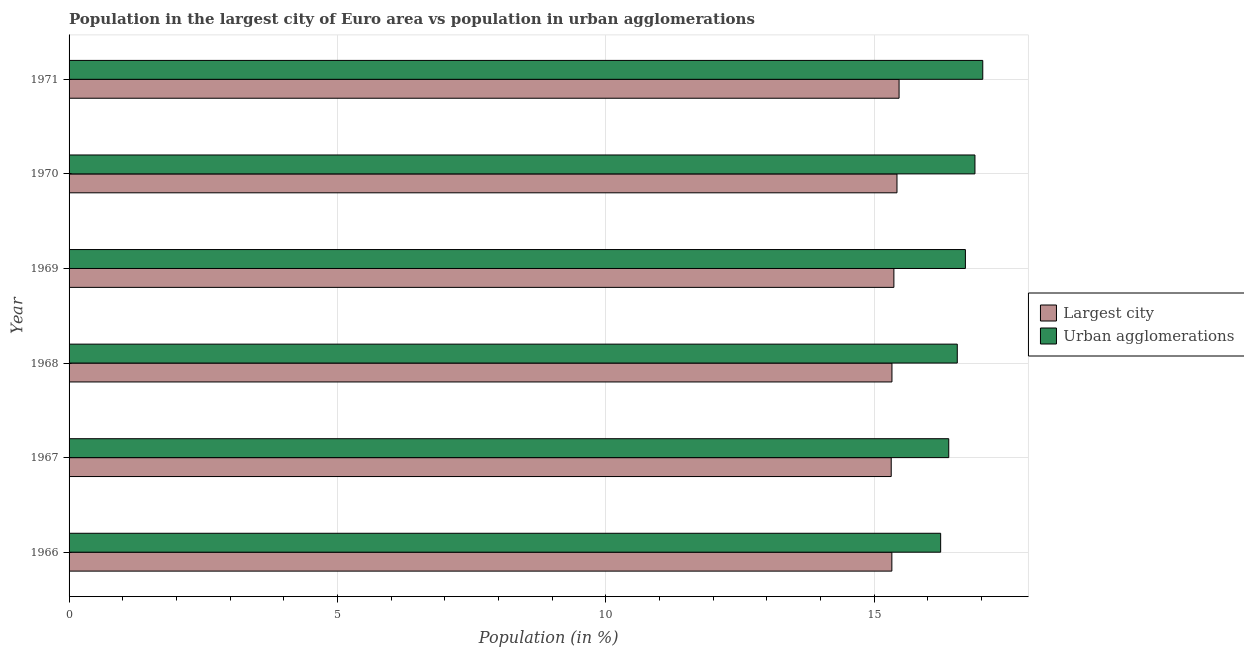How many different coloured bars are there?
Keep it short and to the point. 2. How many groups of bars are there?
Provide a short and direct response. 6. Are the number of bars per tick equal to the number of legend labels?
Ensure brevity in your answer.  Yes. How many bars are there on the 6th tick from the top?
Provide a succinct answer. 2. What is the label of the 5th group of bars from the top?
Provide a short and direct response. 1967. In how many cases, is the number of bars for a given year not equal to the number of legend labels?
Your answer should be very brief. 0. What is the population in the largest city in 1969?
Provide a short and direct response. 15.37. Across all years, what is the maximum population in the largest city?
Provide a short and direct response. 15.47. Across all years, what is the minimum population in the largest city?
Provide a succinct answer. 15.32. In which year was the population in urban agglomerations minimum?
Your response must be concise. 1966. What is the total population in the largest city in the graph?
Provide a short and direct response. 92.24. What is the difference between the population in the largest city in 1967 and that in 1971?
Your response must be concise. -0.15. What is the difference between the population in urban agglomerations in 1971 and the population in the largest city in 1967?
Offer a very short reply. 1.71. What is the average population in the largest city per year?
Offer a terse response. 15.37. In the year 1966, what is the difference between the population in the largest city and population in urban agglomerations?
Offer a very short reply. -0.91. In how many years, is the population in urban agglomerations greater than 9 %?
Your answer should be very brief. 6. What is the ratio of the population in the largest city in 1969 to that in 1970?
Give a very brief answer. 1. Is the difference between the population in the largest city in 1967 and 1970 greater than the difference between the population in urban agglomerations in 1967 and 1970?
Offer a very short reply. Yes. What is the difference between the highest and the second highest population in urban agglomerations?
Your answer should be compact. 0.14. Is the sum of the population in urban agglomerations in 1967 and 1971 greater than the maximum population in the largest city across all years?
Offer a very short reply. Yes. What does the 2nd bar from the top in 1966 represents?
Keep it short and to the point. Largest city. What does the 2nd bar from the bottom in 1970 represents?
Offer a terse response. Urban agglomerations. Does the graph contain grids?
Your answer should be very brief. Yes. What is the title of the graph?
Offer a terse response. Population in the largest city of Euro area vs population in urban agglomerations. Does "IMF concessional" appear as one of the legend labels in the graph?
Give a very brief answer. No. What is the label or title of the X-axis?
Your answer should be very brief. Population (in %). What is the Population (in %) in Largest city in 1966?
Make the answer very short. 15.33. What is the Population (in %) of Urban agglomerations in 1966?
Offer a terse response. 16.24. What is the Population (in %) in Largest city in 1967?
Ensure brevity in your answer.  15.32. What is the Population (in %) in Urban agglomerations in 1967?
Your answer should be compact. 16.39. What is the Population (in %) of Largest city in 1968?
Provide a succinct answer. 15.33. What is the Population (in %) in Urban agglomerations in 1968?
Your answer should be compact. 16.55. What is the Population (in %) of Largest city in 1969?
Make the answer very short. 15.37. What is the Population (in %) of Urban agglomerations in 1969?
Give a very brief answer. 16.7. What is the Population (in %) in Largest city in 1970?
Ensure brevity in your answer.  15.43. What is the Population (in %) of Urban agglomerations in 1970?
Provide a short and direct response. 16.88. What is the Population (in %) of Largest city in 1971?
Provide a short and direct response. 15.47. What is the Population (in %) of Urban agglomerations in 1971?
Offer a terse response. 17.02. Across all years, what is the maximum Population (in %) in Largest city?
Provide a short and direct response. 15.47. Across all years, what is the maximum Population (in %) in Urban agglomerations?
Give a very brief answer. 17.02. Across all years, what is the minimum Population (in %) of Largest city?
Offer a very short reply. 15.32. Across all years, what is the minimum Population (in %) of Urban agglomerations?
Provide a succinct answer. 16.24. What is the total Population (in %) of Largest city in the graph?
Ensure brevity in your answer.  92.24. What is the total Population (in %) of Urban agglomerations in the graph?
Ensure brevity in your answer.  99.79. What is the difference between the Population (in %) in Largest city in 1966 and that in 1967?
Give a very brief answer. 0.01. What is the difference between the Population (in %) in Urban agglomerations in 1966 and that in 1967?
Ensure brevity in your answer.  -0.15. What is the difference between the Population (in %) of Largest city in 1966 and that in 1968?
Your response must be concise. -0. What is the difference between the Population (in %) in Urban agglomerations in 1966 and that in 1968?
Make the answer very short. -0.31. What is the difference between the Population (in %) of Largest city in 1966 and that in 1969?
Your answer should be compact. -0.04. What is the difference between the Population (in %) of Urban agglomerations in 1966 and that in 1969?
Your response must be concise. -0.46. What is the difference between the Population (in %) in Largest city in 1966 and that in 1970?
Keep it short and to the point. -0.1. What is the difference between the Population (in %) of Urban agglomerations in 1966 and that in 1970?
Your answer should be very brief. -0.64. What is the difference between the Population (in %) of Largest city in 1966 and that in 1971?
Make the answer very short. -0.13. What is the difference between the Population (in %) of Urban agglomerations in 1966 and that in 1971?
Give a very brief answer. -0.78. What is the difference between the Population (in %) of Largest city in 1967 and that in 1968?
Offer a very short reply. -0.01. What is the difference between the Population (in %) in Urban agglomerations in 1967 and that in 1968?
Your answer should be compact. -0.16. What is the difference between the Population (in %) of Urban agglomerations in 1967 and that in 1969?
Give a very brief answer. -0.31. What is the difference between the Population (in %) in Largest city in 1967 and that in 1970?
Your answer should be compact. -0.11. What is the difference between the Population (in %) of Urban agglomerations in 1967 and that in 1970?
Keep it short and to the point. -0.49. What is the difference between the Population (in %) in Largest city in 1967 and that in 1971?
Provide a short and direct response. -0.15. What is the difference between the Population (in %) in Urban agglomerations in 1967 and that in 1971?
Give a very brief answer. -0.63. What is the difference between the Population (in %) of Largest city in 1968 and that in 1969?
Provide a succinct answer. -0.04. What is the difference between the Population (in %) of Urban agglomerations in 1968 and that in 1969?
Give a very brief answer. -0.15. What is the difference between the Population (in %) in Largest city in 1968 and that in 1970?
Keep it short and to the point. -0.09. What is the difference between the Population (in %) in Urban agglomerations in 1968 and that in 1970?
Ensure brevity in your answer.  -0.33. What is the difference between the Population (in %) in Largest city in 1968 and that in 1971?
Offer a very short reply. -0.13. What is the difference between the Population (in %) in Urban agglomerations in 1968 and that in 1971?
Your answer should be very brief. -0.47. What is the difference between the Population (in %) in Largest city in 1969 and that in 1970?
Make the answer very short. -0.06. What is the difference between the Population (in %) in Urban agglomerations in 1969 and that in 1970?
Your response must be concise. -0.18. What is the difference between the Population (in %) of Largest city in 1969 and that in 1971?
Provide a succinct answer. -0.1. What is the difference between the Population (in %) of Urban agglomerations in 1969 and that in 1971?
Offer a very short reply. -0.32. What is the difference between the Population (in %) in Largest city in 1970 and that in 1971?
Provide a short and direct response. -0.04. What is the difference between the Population (in %) in Urban agglomerations in 1970 and that in 1971?
Provide a short and direct response. -0.15. What is the difference between the Population (in %) in Largest city in 1966 and the Population (in %) in Urban agglomerations in 1967?
Give a very brief answer. -1.06. What is the difference between the Population (in %) in Largest city in 1966 and the Population (in %) in Urban agglomerations in 1968?
Make the answer very short. -1.22. What is the difference between the Population (in %) in Largest city in 1966 and the Population (in %) in Urban agglomerations in 1969?
Provide a short and direct response. -1.37. What is the difference between the Population (in %) in Largest city in 1966 and the Population (in %) in Urban agglomerations in 1970?
Make the answer very short. -1.55. What is the difference between the Population (in %) in Largest city in 1966 and the Population (in %) in Urban agglomerations in 1971?
Offer a terse response. -1.69. What is the difference between the Population (in %) in Largest city in 1967 and the Population (in %) in Urban agglomerations in 1968?
Keep it short and to the point. -1.23. What is the difference between the Population (in %) in Largest city in 1967 and the Population (in %) in Urban agglomerations in 1969?
Your answer should be compact. -1.38. What is the difference between the Population (in %) in Largest city in 1967 and the Population (in %) in Urban agglomerations in 1970?
Offer a terse response. -1.56. What is the difference between the Population (in %) in Largest city in 1967 and the Population (in %) in Urban agglomerations in 1971?
Provide a short and direct response. -1.71. What is the difference between the Population (in %) of Largest city in 1968 and the Population (in %) of Urban agglomerations in 1969?
Ensure brevity in your answer.  -1.37. What is the difference between the Population (in %) of Largest city in 1968 and the Population (in %) of Urban agglomerations in 1970?
Offer a terse response. -1.55. What is the difference between the Population (in %) in Largest city in 1968 and the Population (in %) in Urban agglomerations in 1971?
Provide a short and direct response. -1.69. What is the difference between the Population (in %) of Largest city in 1969 and the Population (in %) of Urban agglomerations in 1970?
Offer a very short reply. -1.51. What is the difference between the Population (in %) in Largest city in 1969 and the Population (in %) in Urban agglomerations in 1971?
Ensure brevity in your answer.  -1.66. What is the difference between the Population (in %) of Largest city in 1970 and the Population (in %) of Urban agglomerations in 1971?
Keep it short and to the point. -1.6. What is the average Population (in %) in Largest city per year?
Give a very brief answer. 15.37. What is the average Population (in %) of Urban agglomerations per year?
Provide a short and direct response. 16.63. In the year 1966, what is the difference between the Population (in %) of Largest city and Population (in %) of Urban agglomerations?
Ensure brevity in your answer.  -0.91. In the year 1967, what is the difference between the Population (in %) in Largest city and Population (in %) in Urban agglomerations?
Offer a terse response. -1.07. In the year 1968, what is the difference between the Population (in %) of Largest city and Population (in %) of Urban agglomerations?
Your response must be concise. -1.22. In the year 1969, what is the difference between the Population (in %) in Largest city and Population (in %) in Urban agglomerations?
Give a very brief answer. -1.33. In the year 1970, what is the difference between the Population (in %) of Largest city and Population (in %) of Urban agglomerations?
Ensure brevity in your answer.  -1.45. In the year 1971, what is the difference between the Population (in %) in Largest city and Population (in %) in Urban agglomerations?
Offer a very short reply. -1.56. What is the ratio of the Population (in %) in Urban agglomerations in 1966 to that in 1967?
Provide a succinct answer. 0.99. What is the ratio of the Population (in %) of Largest city in 1966 to that in 1968?
Make the answer very short. 1. What is the ratio of the Population (in %) in Urban agglomerations in 1966 to that in 1968?
Offer a very short reply. 0.98. What is the ratio of the Population (in %) in Urban agglomerations in 1966 to that in 1969?
Keep it short and to the point. 0.97. What is the ratio of the Population (in %) in Urban agglomerations in 1966 to that in 1970?
Your answer should be very brief. 0.96. What is the ratio of the Population (in %) in Largest city in 1966 to that in 1971?
Offer a very short reply. 0.99. What is the ratio of the Population (in %) of Urban agglomerations in 1966 to that in 1971?
Provide a short and direct response. 0.95. What is the ratio of the Population (in %) of Largest city in 1967 to that in 1968?
Your answer should be compact. 1. What is the ratio of the Population (in %) in Urban agglomerations in 1967 to that in 1969?
Your response must be concise. 0.98. What is the ratio of the Population (in %) in Largest city in 1967 to that in 1970?
Give a very brief answer. 0.99. What is the ratio of the Population (in %) of Urban agglomerations in 1967 to that in 1970?
Keep it short and to the point. 0.97. What is the ratio of the Population (in %) in Urban agglomerations in 1967 to that in 1971?
Your answer should be very brief. 0.96. What is the ratio of the Population (in %) in Urban agglomerations in 1968 to that in 1969?
Offer a very short reply. 0.99. What is the ratio of the Population (in %) in Urban agglomerations in 1968 to that in 1970?
Give a very brief answer. 0.98. What is the ratio of the Population (in %) of Largest city in 1968 to that in 1971?
Keep it short and to the point. 0.99. What is the ratio of the Population (in %) in Urban agglomerations in 1968 to that in 1971?
Your answer should be compact. 0.97. What is the ratio of the Population (in %) in Largest city in 1969 to that in 1970?
Make the answer very short. 1. What is the ratio of the Population (in %) in Urban agglomerations in 1969 to that in 1970?
Your response must be concise. 0.99. What is the ratio of the Population (in %) in Largest city in 1969 to that in 1971?
Your answer should be compact. 0.99. What is the difference between the highest and the second highest Population (in %) of Largest city?
Your answer should be very brief. 0.04. What is the difference between the highest and the second highest Population (in %) of Urban agglomerations?
Ensure brevity in your answer.  0.15. What is the difference between the highest and the lowest Population (in %) in Largest city?
Keep it short and to the point. 0.15. What is the difference between the highest and the lowest Population (in %) in Urban agglomerations?
Offer a very short reply. 0.78. 